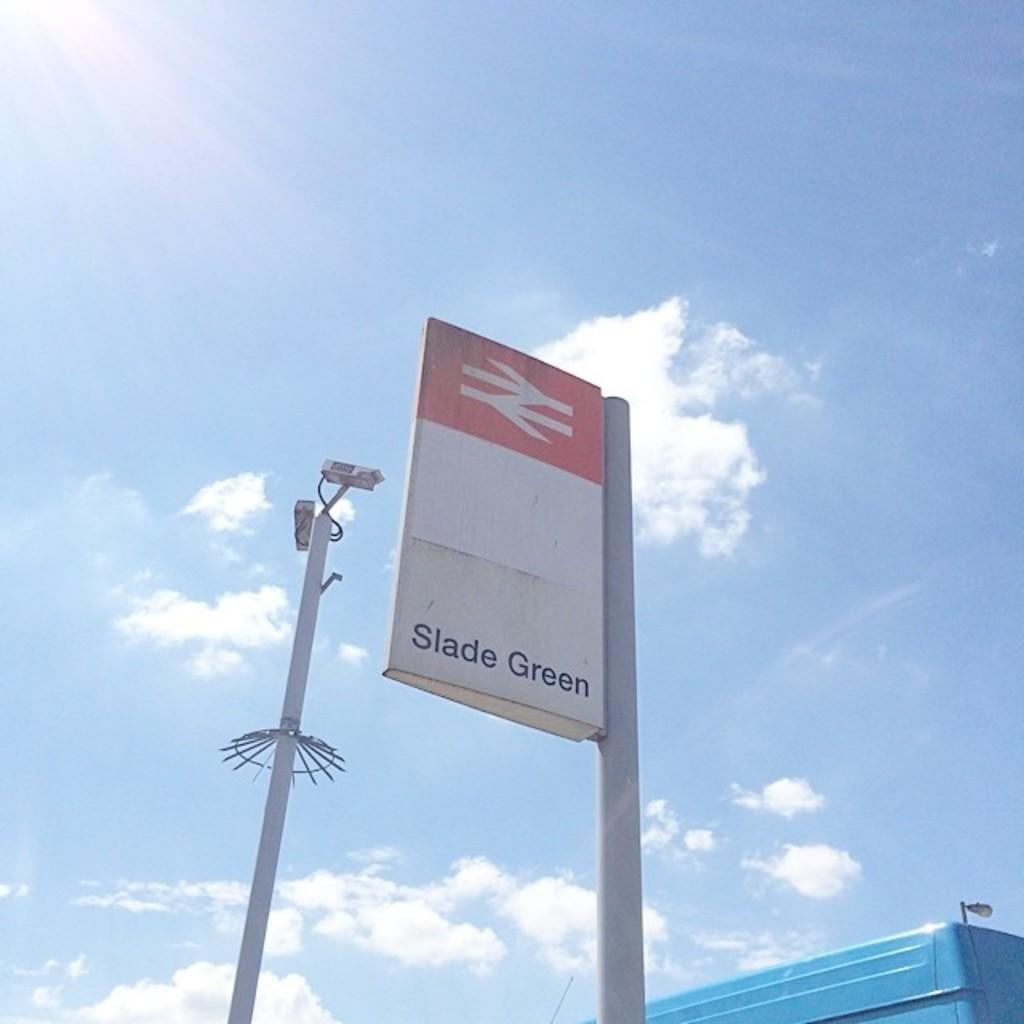<image>
Write a terse but informative summary of the picture. Banner on a pole that says Slade Green. 